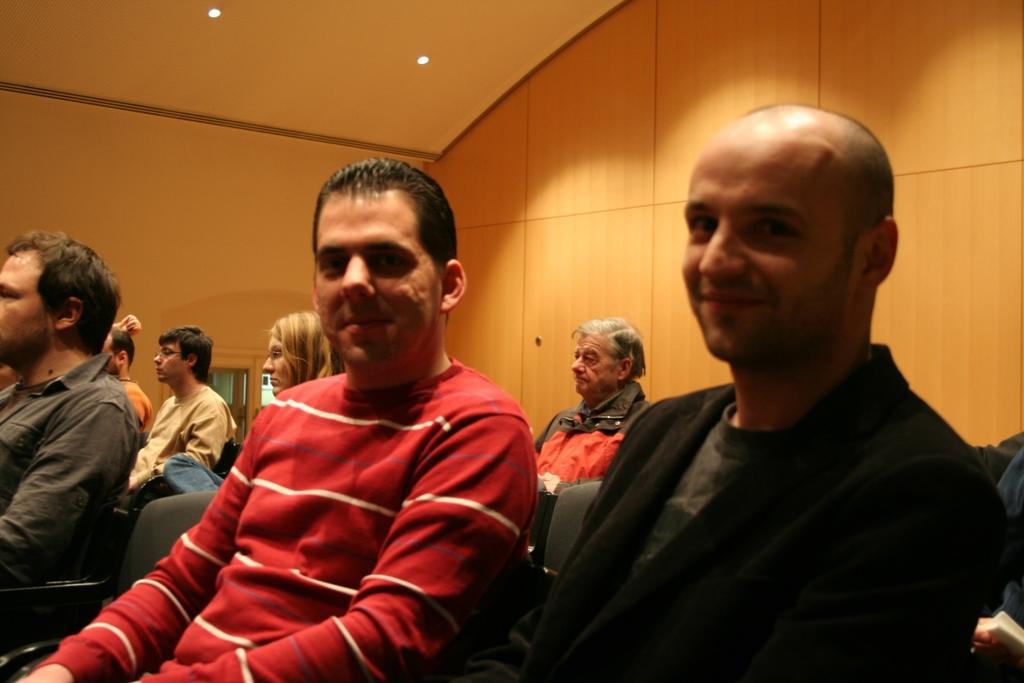Describe this image in one or two sentences. In this image we can see a group of people sitting on the chairs. On the backside we can see a wall, door and a roof with some ceiling lights. 